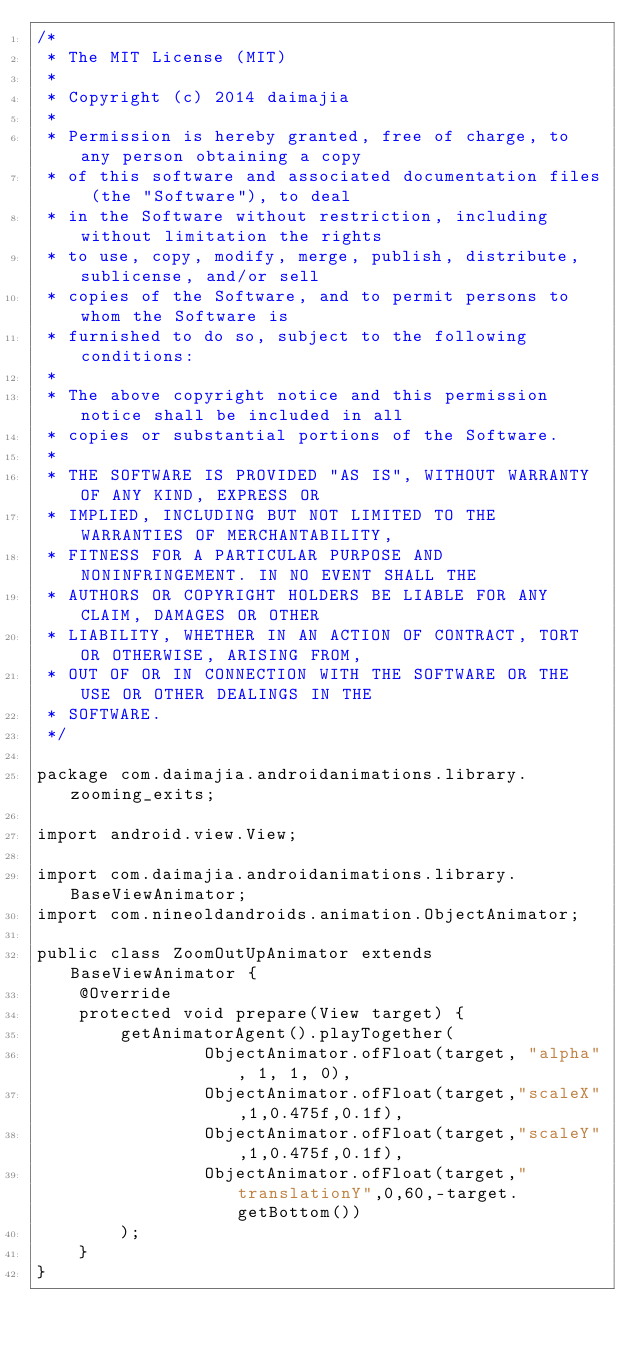<code> <loc_0><loc_0><loc_500><loc_500><_Java_>/*
 * The MIT License (MIT)
 *
 * Copyright (c) 2014 daimajia
 *
 * Permission is hereby granted, free of charge, to any person obtaining a copy
 * of this software and associated documentation files (the "Software"), to deal
 * in the Software without restriction, including without limitation the rights
 * to use, copy, modify, merge, publish, distribute, sublicense, and/or sell
 * copies of the Software, and to permit persons to whom the Software is
 * furnished to do so, subject to the following conditions:
 *
 * The above copyright notice and this permission notice shall be included in all
 * copies or substantial portions of the Software.
 *
 * THE SOFTWARE IS PROVIDED "AS IS", WITHOUT WARRANTY OF ANY KIND, EXPRESS OR
 * IMPLIED, INCLUDING BUT NOT LIMITED TO THE WARRANTIES OF MERCHANTABILITY,
 * FITNESS FOR A PARTICULAR PURPOSE AND NONINFRINGEMENT. IN NO EVENT SHALL THE
 * AUTHORS OR COPYRIGHT HOLDERS BE LIABLE FOR ANY CLAIM, DAMAGES OR OTHER
 * LIABILITY, WHETHER IN AN ACTION OF CONTRACT, TORT OR OTHERWISE, ARISING FROM,
 * OUT OF OR IN CONNECTION WITH THE SOFTWARE OR THE USE OR OTHER DEALINGS IN THE
 * SOFTWARE.
 */

package com.daimajia.androidanimations.library.zooming_exits;

import android.view.View;

import com.daimajia.androidanimations.library.BaseViewAnimator;
import com.nineoldandroids.animation.ObjectAnimator;

public class ZoomOutUpAnimator extends BaseViewAnimator {
    @Override
    protected void prepare(View target) {
        getAnimatorAgent().playTogether(
                ObjectAnimator.ofFloat(target, "alpha", 1, 1, 0),
                ObjectAnimator.ofFloat(target,"scaleX",1,0.475f,0.1f),
                ObjectAnimator.ofFloat(target,"scaleY",1,0.475f,0.1f),
                ObjectAnimator.ofFloat(target,"translationY",0,60,-target.getBottom())
        );
    }
}
</code> 